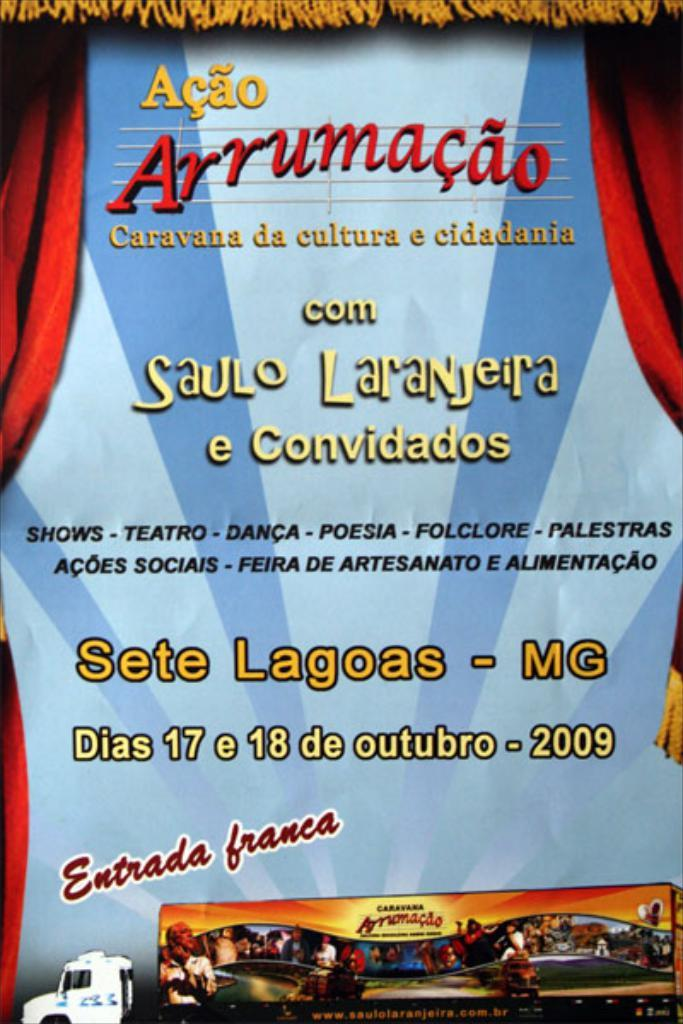<image>
Present a compact description of the photo's key features. poster for acao arrumacao that is on dias 17 e 18 de outubro - 2009 